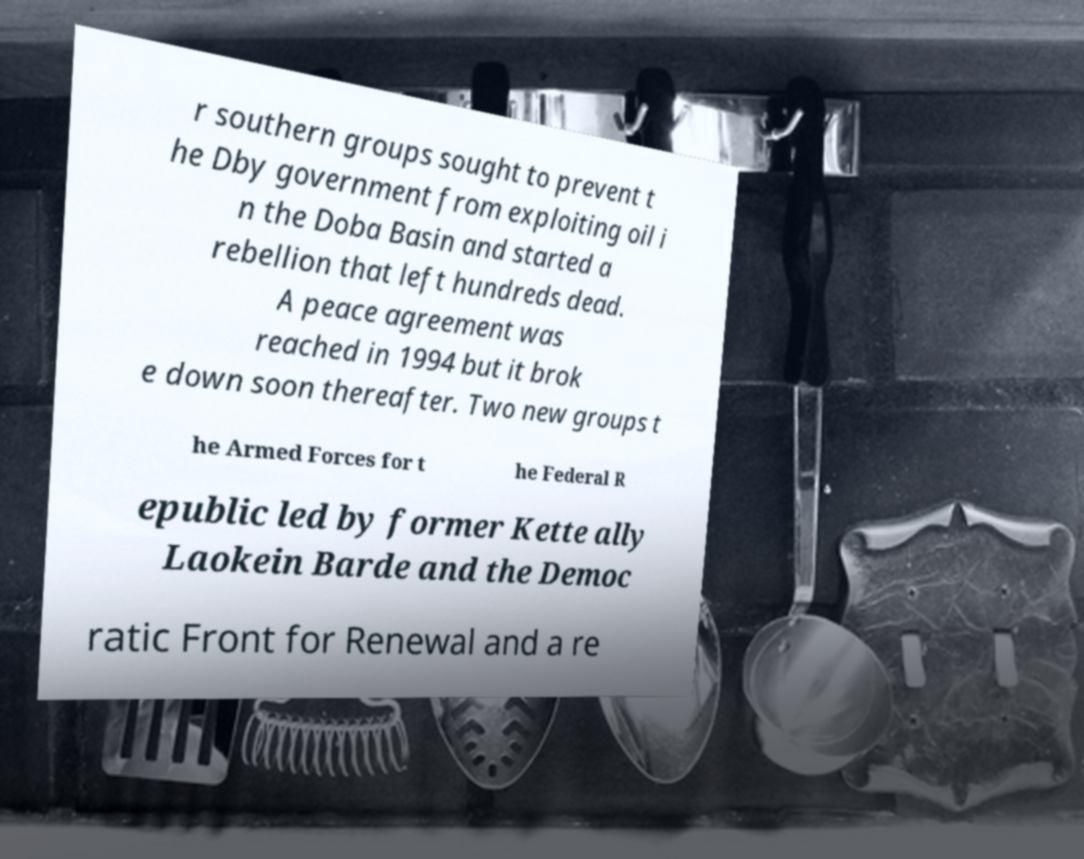I need the written content from this picture converted into text. Can you do that? r southern groups sought to prevent t he Dby government from exploiting oil i n the Doba Basin and started a rebellion that left hundreds dead. A peace agreement was reached in 1994 but it brok e down soon thereafter. Two new groups t he Armed Forces for t he Federal R epublic led by former Kette ally Laokein Barde and the Democ ratic Front for Renewal and a re 